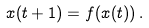<formula> <loc_0><loc_0><loc_500><loc_500>x ( t + 1 ) = f ( x ( t ) ) \, .</formula> 